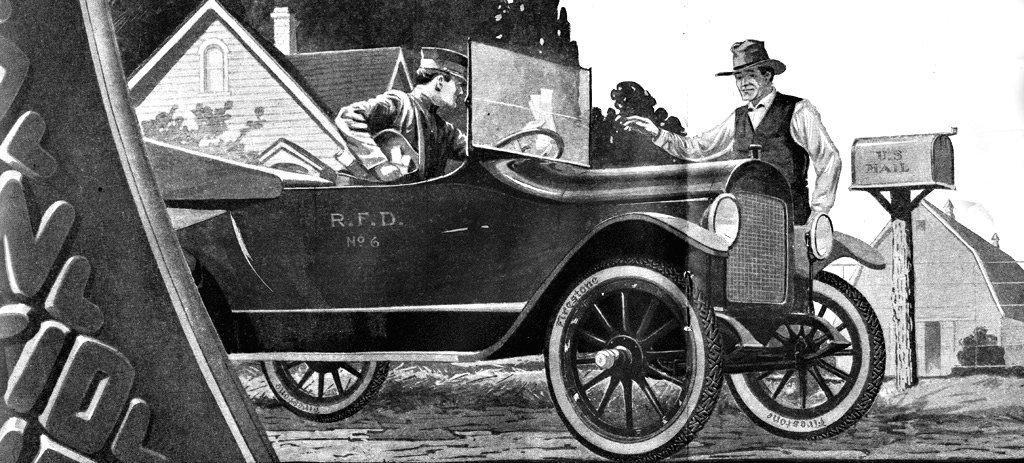Can you describe this image briefly? In this picture I can see a vehicle on the road, there are two persons, houses, a mailbox with a pole, and there is sky. 